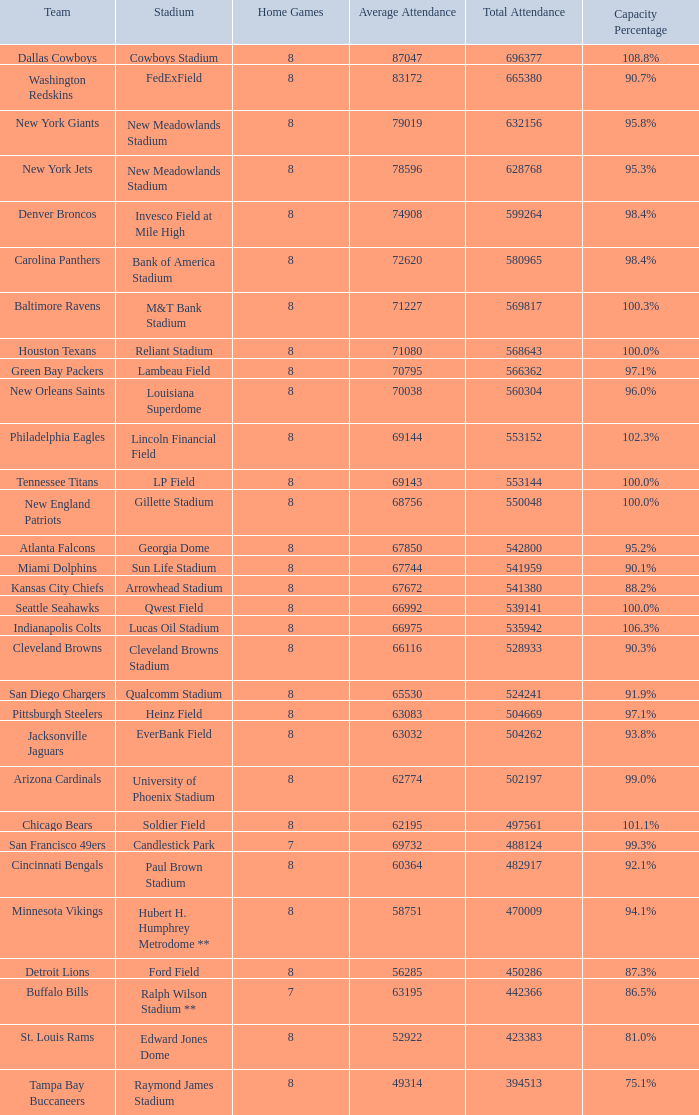What team had a capacity of 102.3%? Philadelphia Eagles. 